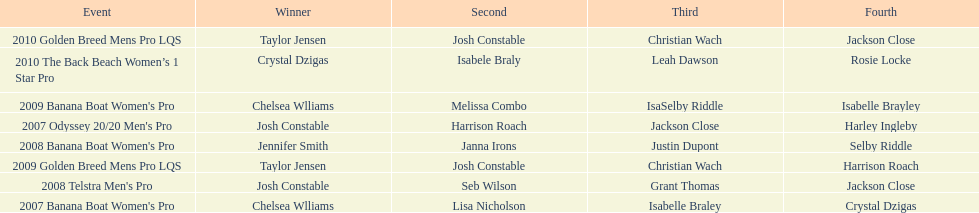In what event did chelsea williams win her first title? 2007 Banana Boat Women's Pro. 